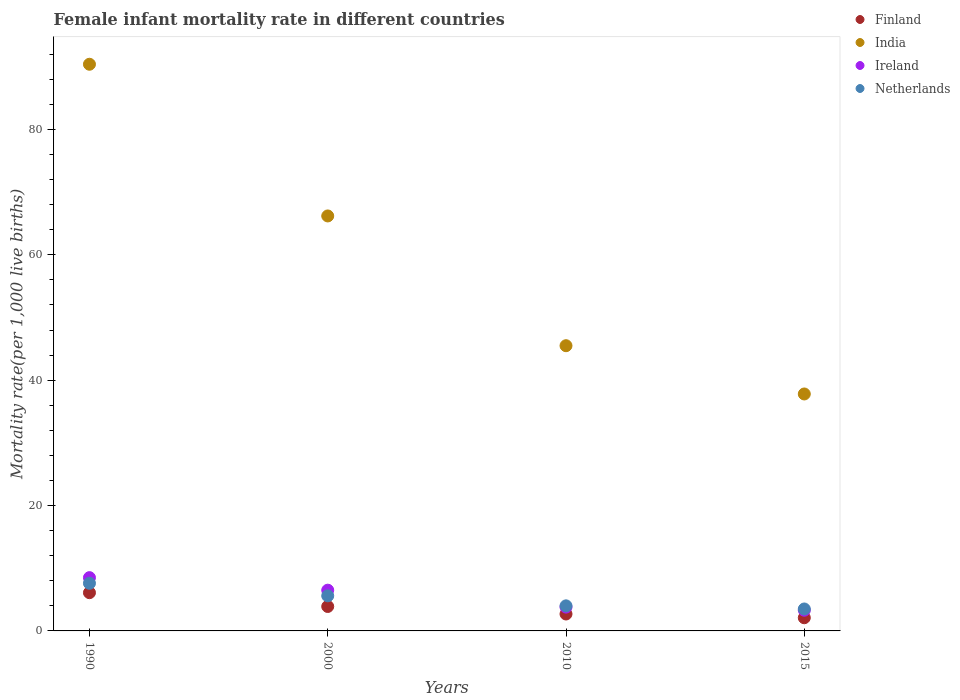How many different coloured dotlines are there?
Your answer should be very brief. 4. Across all years, what is the minimum female infant mortality rate in India?
Offer a terse response. 37.8. In which year was the female infant mortality rate in Ireland maximum?
Your answer should be very brief. 1990. In which year was the female infant mortality rate in Ireland minimum?
Offer a very short reply. 2015. What is the total female infant mortality rate in Netherlands in the graph?
Your answer should be compact. 20.7. What is the difference between the female infant mortality rate in Finland in 2000 and that in 2015?
Your response must be concise. 1.8. What is the difference between the female infant mortality rate in Finland in 1990 and the female infant mortality rate in India in 2010?
Your response must be concise. -39.4. What is the average female infant mortality rate in Ireland per year?
Make the answer very short. 5.53. In the year 2000, what is the difference between the female infant mortality rate in India and female infant mortality rate in Finland?
Provide a short and direct response. 62.3. In how many years, is the female infant mortality rate in Finland greater than 64?
Provide a short and direct response. 0. What is the ratio of the female infant mortality rate in Ireland in 2000 to that in 2010?
Offer a terse response. 1.71. Is the female infant mortality rate in Netherlands in 2000 less than that in 2015?
Your response must be concise. No. Is the difference between the female infant mortality rate in India in 2010 and 2015 greater than the difference between the female infant mortality rate in Finland in 2010 and 2015?
Keep it short and to the point. Yes. What is the difference between the highest and the lowest female infant mortality rate in Netherlands?
Your answer should be compact. 4.1. In how many years, is the female infant mortality rate in Netherlands greater than the average female infant mortality rate in Netherlands taken over all years?
Your answer should be very brief. 2. Is it the case that in every year, the sum of the female infant mortality rate in Ireland and female infant mortality rate in Finland  is greater than the sum of female infant mortality rate in Netherlands and female infant mortality rate in India?
Provide a succinct answer. Yes. Is it the case that in every year, the sum of the female infant mortality rate in India and female infant mortality rate in Netherlands  is greater than the female infant mortality rate in Ireland?
Provide a short and direct response. Yes. Does the female infant mortality rate in India monotonically increase over the years?
Offer a very short reply. No. Is the female infant mortality rate in Finland strictly greater than the female infant mortality rate in Netherlands over the years?
Your response must be concise. No. Does the graph contain grids?
Offer a very short reply. No. How many legend labels are there?
Provide a succinct answer. 4. What is the title of the graph?
Offer a very short reply. Female infant mortality rate in different countries. Does "Zimbabwe" appear as one of the legend labels in the graph?
Give a very brief answer. No. What is the label or title of the X-axis?
Offer a terse response. Years. What is the label or title of the Y-axis?
Keep it short and to the point. Mortality rate(per 1,0 live births). What is the Mortality rate(per 1,000 live births) of Finland in 1990?
Keep it short and to the point. 6.1. What is the Mortality rate(per 1,000 live births) in India in 1990?
Make the answer very short. 90.4. What is the Mortality rate(per 1,000 live births) of Finland in 2000?
Offer a very short reply. 3.9. What is the Mortality rate(per 1,000 live births) of India in 2000?
Your response must be concise. 66.2. What is the Mortality rate(per 1,000 live births) in Ireland in 2000?
Give a very brief answer. 6.5. What is the Mortality rate(per 1,000 live births) of India in 2010?
Your answer should be compact. 45.5. What is the Mortality rate(per 1,000 live births) of Ireland in 2010?
Offer a very short reply. 3.8. What is the Mortality rate(per 1,000 live births) of India in 2015?
Make the answer very short. 37.8. What is the Mortality rate(per 1,000 live births) of Ireland in 2015?
Ensure brevity in your answer.  3.3. What is the Mortality rate(per 1,000 live births) of Netherlands in 2015?
Provide a short and direct response. 3.5. Across all years, what is the maximum Mortality rate(per 1,000 live births) of India?
Make the answer very short. 90.4. Across all years, what is the minimum Mortality rate(per 1,000 live births) of Finland?
Your response must be concise. 2.1. Across all years, what is the minimum Mortality rate(per 1,000 live births) of India?
Keep it short and to the point. 37.8. Across all years, what is the minimum Mortality rate(per 1,000 live births) of Ireland?
Ensure brevity in your answer.  3.3. What is the total Mortality rate(per 1,000 live births) of India in the graph?
Your response must be concise. 239.9. What is the total Mortality rate(per 1,000 live births) in Ireland in the graph?
Your answer should be compact. 22.1. What is the total Mortality rate(per 1,000 live births) in Netherlands in the graph?
Give a very brief answer. 20.7. What is the difference between the Mortality rate(per 1,000 live births) in Finland in 1990 and that in 2000?
Keep it short and to the point. 2.2. What is the difference between the Mortality rate(per 1,000 live births) in India in 1990 and that in 2000?
Offer a very short reply. 24.2. What is the difference between the Mortality rate(per 1,000 live births) in Finland in 1990 and that in 2010?
Offer a terse response. 3.4. What is the difference between the Mortality rate(per 1,000 live births) in India in 1990 and that in 2010?
Keep it short and to the point. 44.9. What is the difference between the Mortality rate(per 1,000 live births) in India in 1990 and that in 2015?
Give a very brief answer. 52.6. What is the difference between the Mortality rate(per 1,000 live births) of Ireland in 1990 and that in 2015?
Your answer should be very brief. 5.2. What is the difference between the Mortality rate(per 1,000 live births) in Netherlands in 1990 and that in 2015?
Make the answer very short. 4.1. What is the difference between the Mortality rate(per 1,000 live births) of India in 2000 and that in 2010?
Provide a succinct answer. 20.7. What is the difference between the Mortality rate(per 1,000 live births) of India in 2000 and that in 2015?
Keep it short and to the point. 28.4. What is the difference between the Mortality rate(per 1,000 live births) of Ireland in 2000 and that in 2015?
Offer a very short reply. 3.2. What is the difference between the Mortality rate(per 1,000 live births) of Netherlands in 2010 and that in 2015?
Make the answer very short. 0.5. What is the difference between the Mortality rate(per 1,000 live births) of Finland in 1990 and the Mortality rate(per 1,000 live births) of India in 2000?
Your answer should be very brief. -60.1. What is the difference between the Mortality rate(per 1,000 live births) in Finland in 1990 and the Mortality rate(per 1,000 live births) in Ireland in 2000?
Give a very brief answer. -0.4. What is the difference between the Mortality rate(per 1,000 live births) in India in 1990 and the Mortality rate(per 1,000 live births) in Ireland in 2000?
Keep it short and to the point. 83.9. What is the difference between the Mortality rate(per 1,000 live births) of India in 1990 and the Mortality rate(per 1,000 live births) of Netherlands in 2000?
Your response must be concise. 84.8. What is the difference between the Mortality rate(per 1,000 live births) of Finland in 1990 and the Mortality rate(per 1,000 live births) of India in 2010?
Give a very brief answer. -39.4. What is the difference between the Mortality rate(per 1,000 live births) of India in 1990 and the Mortality rate(per 1,000 live births) of Ireland in 2010?
Give a very brief answer. 86.6. What is the difference between the Mortality rate(per 1,000 live births) in India in 1990 and the Mortality rate(per 1,000 live births) in Netherlands in 2010?
Provide a short and direct response. 86.4. What is the difference between the Mortality rate(per 1,000 live births) of Ireland in 1990 and the Mortality rate(per 1,000 live births) of Netherlands in 2010?
Your answer should be compact. 4.5. What is the difference between the Mortality rate(per 1,000 live births) in Finland in 1990 and the Mortality rate(per 1,000 live births) in India in 2015?
Keep it short and to the point. -31.7. What is the difference between the Mortality rate(per 1,000 live births) in Finland in 1990 and the Mortality rate(per 1,000 live births) in Netherlands in 2015?
Offer a very short reply. 2.6. What is the difference between the Mortality rate(per 1,000 live births) in India in 1990 and the Mortality rate(per 1,000 live births) in Ireland in 2015?
Provide a short and direct response. 87.1. What is the difference between the Mortality rate(per 1,000 live births) in India in 1990 and the Mortality rate(per 1,000 live births) in Netherlands in 2015?
Your response must be concise. 86.9. What is the difference between the Mortality rate(per 1,000 live births) of Ireland in 1990 and the Mortality rate(per 1,000 live births) of Netherlands in 2015?
Provide a succinct answer. 5. What is the difference between the Mortality rate(per 1,000 live births) in Finland in 2000 and the Mortality rate(per 1,000 live births) in India in 2010?
Offer a terse response. -41.6. What is the difference between the Mortality rate(per 1,000 live births) in Finland in 2000 and the Mortality rate(per 1,000 live births) in Netherlands in 2010?
Offer a very short reply. -0.1. What is the difference between the Mortality rate(per 1,000 live births) of India in 2000 and the Mortality rate(per 1,000 live births) of Ireland in 2010?
Give a very brief answer. 62.4. What is the difference between the Mortality rate(per 1,000 live births) of India in 2000 and the Mortality rate(per 1,000 live births) of Netherlands in 2010?
Ensure brevity in your answer.  62.2. What is the difference between the Mortality rate(per 1,000 live births) of Ireland in 2000 and the Mortality rate(per 1,000 live births) of Netherlands in 2010?
Offer a terse response. 2.5. What is the difference between the Mortality rate(per 1,000 live births) in Finland in 2000 and the Mortality rate(per 1,000 live births) in India in 2015?
Give a very brief answer. -33.9. What is the difference between the Mortality rate(per 1,000 live births) of Finland in 2000 and the Mortality rate(per 1,000 live births) of Ireland in 2015?
Make the answer very short. 0.6. What is the difference between the Mortality rate(per 1,000 live births) in India in 2000 and the Mortality rate(per 1,000 live births) in Ireland in 2015?
Offer a terse response. 62.9. What is the difference between the Mortality rate(per 1,000 live births) in India in 2000 and the Mortality rate(per 1,000 live births) in Netherlands in 2015?
Keep it short and to the point. 62.7. What is the difference between the Mortality rate(per 1,000 live births) in Finland in 2010 and the Mortality rate(per 1,000 live births) in India in 2015?
Give a very brief answer. -35.1. What is the difference between the Mortality rate(per 1,000 live births) of Finland in 2010 and the Mortality rate(per 1,000 live births) of Netherlands in 2015?
Your answer should be compact. -0.8. What is the difference between the Mortality rate(per 1,000 live births) of India in 2010 and the Mortality rate(per 1,000 live births) of Ireland in 2015?
Give a very brief answer. 42.2. What is the difference between the Mortality rate(per 1,000 live births) of Ireland in 2010 and the Mortality rate(per 1,000 live births) of Netherlands in 2015?
Offer a terse response. 0.3. What is the average Mortality rate(per 1,000 live births) of Finland per year?
Your answer should be compact. 3.7. What is the average Mortality rate(per 1,000 live births) of India per year?
Your response must be concise. 59.98. What is the average Mortality rate(per 1,000 live births) in Ireland per year?
Your answer should be compact. 5.53. What is the average Mortality rate(per 1,000 live births) in Netherlands per year?
Make the answer very short. 5.17. In the year 1990, what is the difference between the Mortality rate(per 1,000 live births) in Finland and Mortality rate(per 1,000 live births) in India?
Your answer should be compact. -84.3. In the year 1990, what is the difference between the Mortality rate(per 1,000 live births) of India and Mortality rate(per 1,000 live births) of Ireland?
Your response must be concise. 81.9. In the year 1990, what is the difference between the Mortality rate(per 1,000 live births) in India and Mortality rate(per 1,000 live births) in Netherlands?
Your answer should be very brief. 82.8. In the year 1990, what is the difference between the Mortality rate(per 1,000 live births) in Ireland and Mortality rate(per 1,000 live births) in Netherlands?
Offer a very short reply. 0.9. In the year 2000, what is the difference between the Mortality rate(per 1,000 live births) in Finland and Mortality rate(per 1,000 live births) in India?
Give a very brief answer. -62.3. In the year 2000, what is the difference between the Mortality rate(per 1,000 live births) in Finland and Mortality rate(per 1,000 live births) in Ireland?
Offer a terse response. -2.6. In the year 2000, what is the difference between the Mortality rate(per 1,000 live births) in Finland and Mortality rate(per 1,000 live births) in Netherlands?
Keep it short and to the point. -1.7. In the year 2000, what is the difference between the Mortality rate(per 1,000 live births) in India and Mortality rate(per 1,000 live births) in Ireland?
Your response must be concise. 59.7. In the year 2000, what is the difference between the Mortality rate(per 1,000 live births) of India and Mortality rate(per 1,000 live births) of Netherlands?
Your answer should be compact. 60.6. In the year 2000, what is the difference between the Mortality rate(per 1,000 live births) in Ireland and Mortality rate(per 1,000 live births) in Netherlands?
Keep it short and to the point. 0.9. In the year 2010, what is the difference between the Mortality rate(per 1,000 live births) of Finland and Mortality rate(per 1,000 live births) of India?
Provide a succinct answer. -42.8. In the year 2010, what is the difference between the Mortality rate(per 1,000 live births) in Finland and Mortality rate(per 1,000 live births) in Ireland?
Keep it short and to the point. -1.1. In the year 2010, what is the difference between the Mortality rate(per 1,000 live births) in Finland and Mortality rate(per 1,000 live births) in Netherlands?
Provide a short and direct response. -1.3. In the year 2010, what is the difference between the Mortality rate(per 1,000 live births) of India and Mortality rate(per 1,000 live births) of Ireland?
Your answer should be compact. 41.7. In the year 2010, what is the difference between the Mortality rate(per 1,000 live births) in India and Mortality rate(per 1,000 live births) in Netherlands?
Your response must be concise. 41.5. In the year 2010, what is the difference between the Mortality rate(per 1,000 live births) of Ireland and Mortality rate(per 1,000 live births) of Netherlands?
Ensure brevity in your answer.  -0.2. In the year 2015, what is the difference between the Mortality rate(per 1,000 live births) of Finland and Mortality rate(per 1,000 live births) of India?
Your answer should be very brief. -35.7. In the year 2015, what is the difference between the Mortality rate(per 1,000 live births) in Finland and Mortality rate(per 1,000 live births) in Ireland?
Offer a terse response. -1.2. In the year 2015, what is the difference between the Mortality rate(per 1,000 live births) of India and Mortality rate(per 1,000 live births) of Ireland?
Make the answer very short. 34.5. In the year 2015, what is the difference between the Mortality rate(per 1,000 live births) of India and Mortality rate(per 1,000 live births) of Netherlands?
Keep it short and to the point. 34.3. What is the ratio of the Mortality rate(per 1,000 live births) in Finland in 1990 to that in 2000?
Make the answer very short. 1.56. What is the ratio of the Mortality rate(per 1,000 live births) of India in 1990 to that in 2000?
Offer a very short reply. 1.37. What is the ratio of the Mortality rate(per 1,000 live births) of Ireland in 1990 to that in 2000?
Ensure brevity in your answer.  1.31. What is the ratio of the Mortality rate(per 1,000 live births) in Netherlands in 1990 to that in 2000?
Keep it short and to the point. 1.36. What is the ratio of the Mortality rate(per 1,000 live births) of Finland in 1990 to that in 2010?
Provide a succinct answer. 2.26. What is the ratio of the Mortality rate(per 1,000 live births) of India in 1990 to that in 2010?
Your response must be concise. 1.99. What is the ratio of the Mortality rate(per 1,000 live births) in Ireland in 1990 to that in 2010?
Keep it short and to the point. 2.24. What is the ratio of the Mortality rate(per 1,000 live births) of Finland in 1990 to that in 2015?
Your response must be concise. 2.9. What is the ratio of the Mortality rate(per 1,000 live births) of India in 1990 to that in 2015?
Provide a short and direct response. 2.39. What is the ratio of the Mortality rate(per 1,000 live births) of Ireland in 1990 to that in 2015?
Your answer should be compact. 2.58. What is the ratio of the Mortality rate(per 1,000 live births) in Netherlands in 1990 to that in 2015?
Make the answer very short. 2.17. What is the ratio of the Mortality rate(per 1,000 live births) in Finland in 2000 to that in 2010?
Give a very brief answer. 1.44. What is the ratio of the Mortality rate(per 1,000 live births) of India in 2000 to that in 2010?
Give a very brief answer. 1.45. What is the ratio of the Mortality rate(per 1,000 live births) of Ireland in 2000 to that in 2010?
Keep it short and to the point. 1.71. What is the ratio of the Mortality rate(per 1,000 live births) of Finland in 2000 to that in 2015?
Provide a short and direct response. 1.86. What is the ratio of the Mortality rate(per 1,000 live births) of India in 2000 to that in 2015?
Offer a very short reply. 1.75. What is the ratio of the Mortality rate(per 1,000 live births) of Ireland in 2000 to that in 2015?
Make the answer very short. 1.97. What is the ratio of the Mortality rate(per 1,000 live births) in India in 2010 to that in 2015?
Your answer should be very brief. 1.2. What is the ratio of the Mortality rate(per 1,000 live births) in Ireland in 2010 to that in 2015?
Your answer should be very brief. 1.15. What is the ratio of the Mortality rate(per 1,000 live births) in Netherlands in 2010 to that in 2015?
Offer a very short reply. 1.14. What is the difference between the highest and the second highest Mortality rate(per 1,000 live births) of Finland?
Offer a terse response. 2.2. What is the difference between the highest and the second highest Mortality rate(per 1,000 live births) of India?
Make the answer very short. 24.2. What is the difference between the highest and the lowest Mortality rate(per 1,000 live births) of Finland?
Offer a terse response. 4. What is the difference between the highest and the lowest Mortality rate(per 1,000 live births) in India?
Your answer should be compact. 52.6. What is the difference between the highest and the lowest Mortality rate(per 1,000 live births) of Netherlands?
Give a very brief answer. 4.1. 